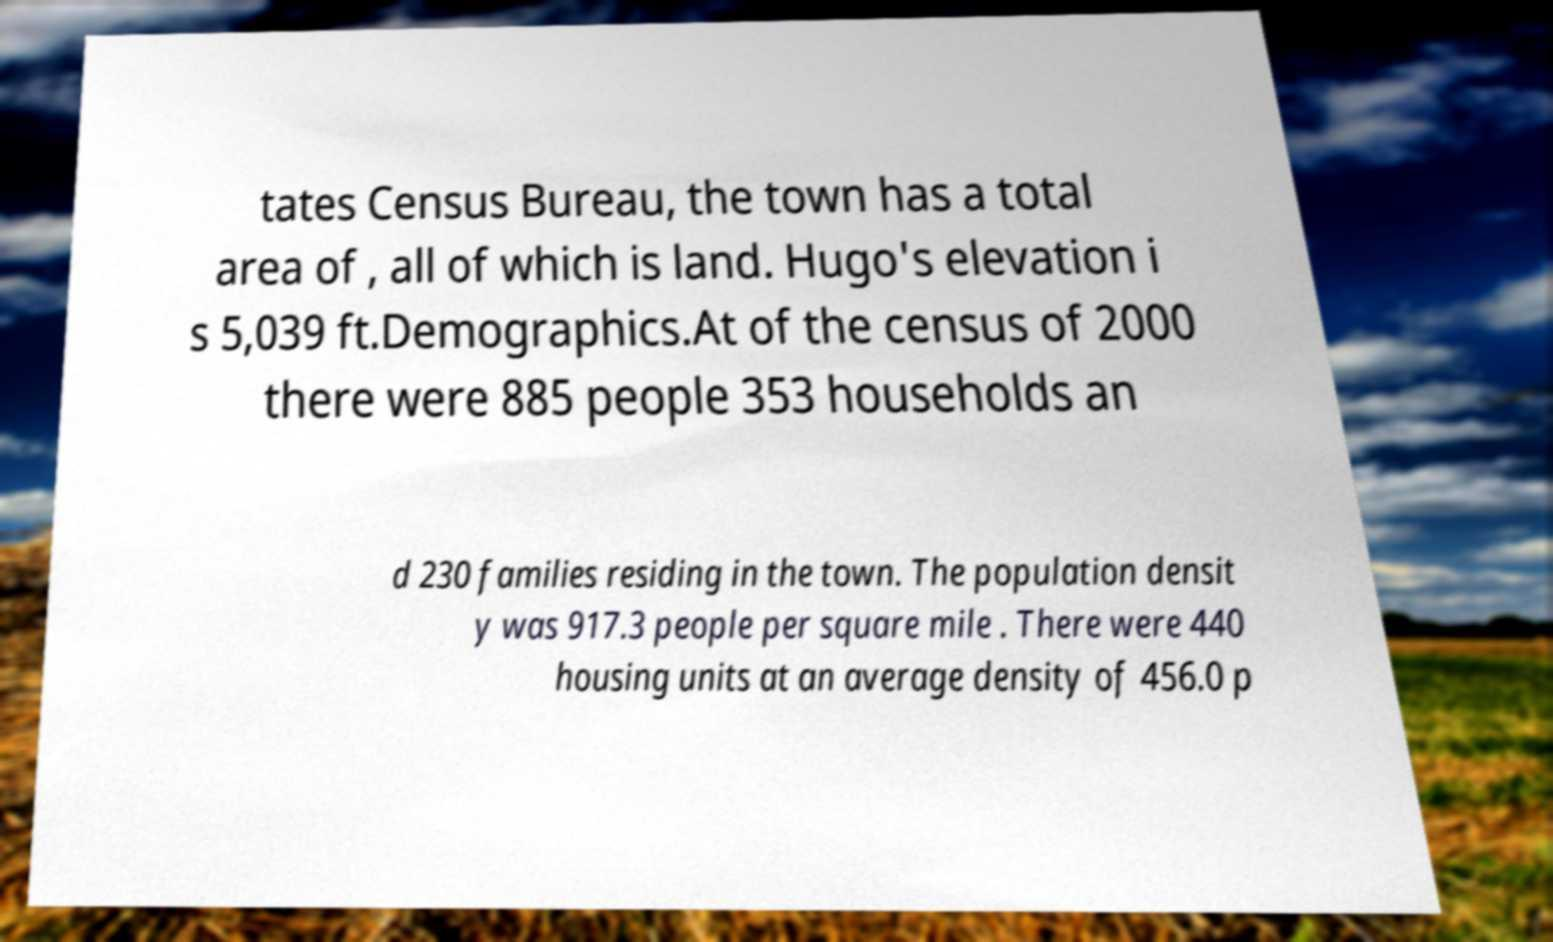Can you read and provide the text displayed in the image?This photo seems to have some interesting text. Can you extract and type it out for me? tates Census Bureau, the town has a total area of , all of which is land. Hugo's elevation i s 5,039 ft.Demographics.At of the census of 2000 there were 885 people 353 households an d 230 families residing in the town. The population densit y was 917.3 people per square mile . There were 440 housing units at an average density of 456.0 p 